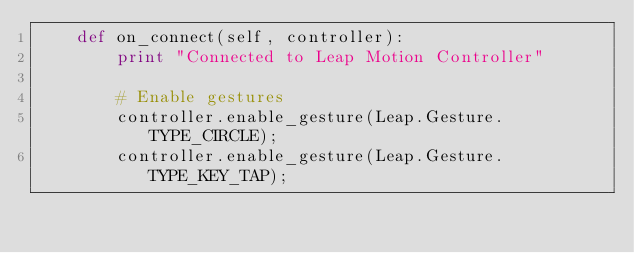<code> <loc_0><loc_0><loc_500><loc_500><_Python_>    def on_connect(self, controller):
        print "Connected to Leap Motion Controller"

        # Enable gestures
        controller.enable_gesture(Leap.Gesture.TYPE_CIRCLE);
        controller.enable_gesture(Leap.Gesture.TYPE_KEY_TAP);</code> 